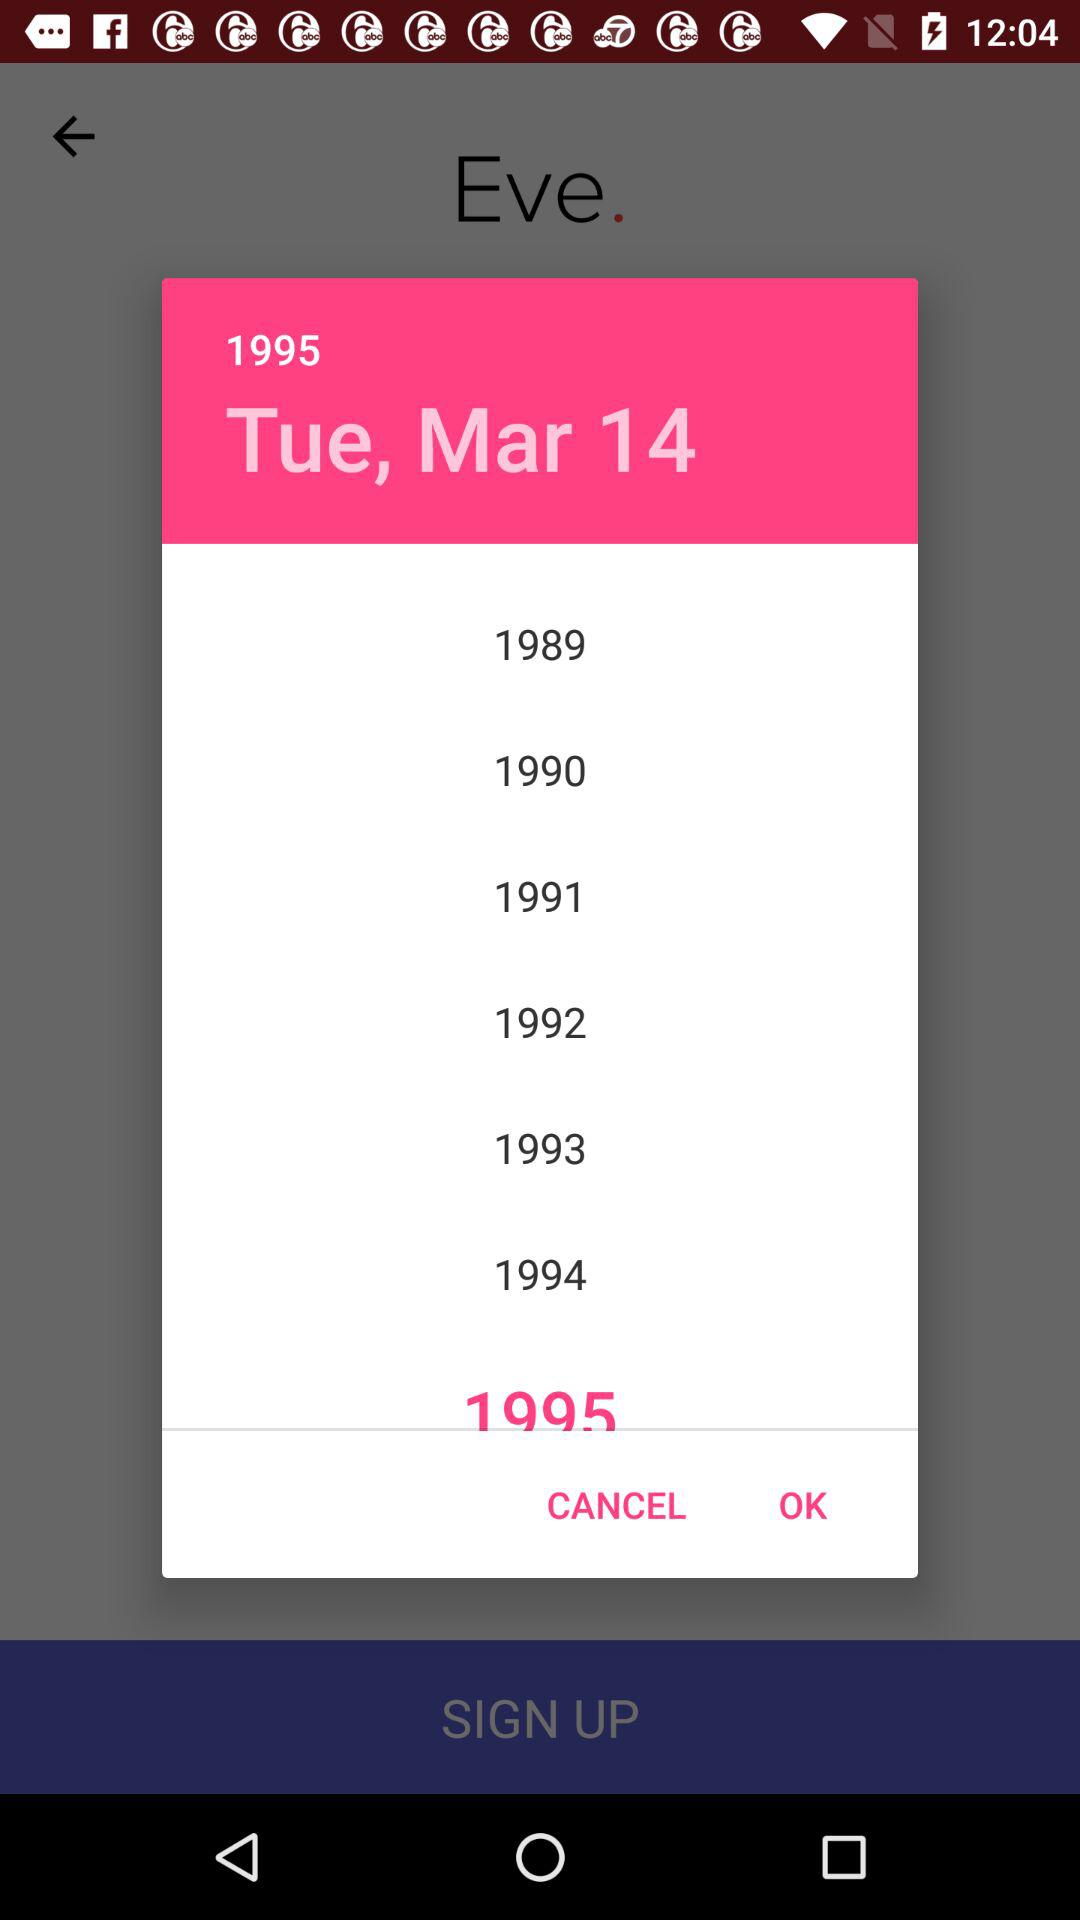What day is mentioned? The mentioned day is Tuesday. 